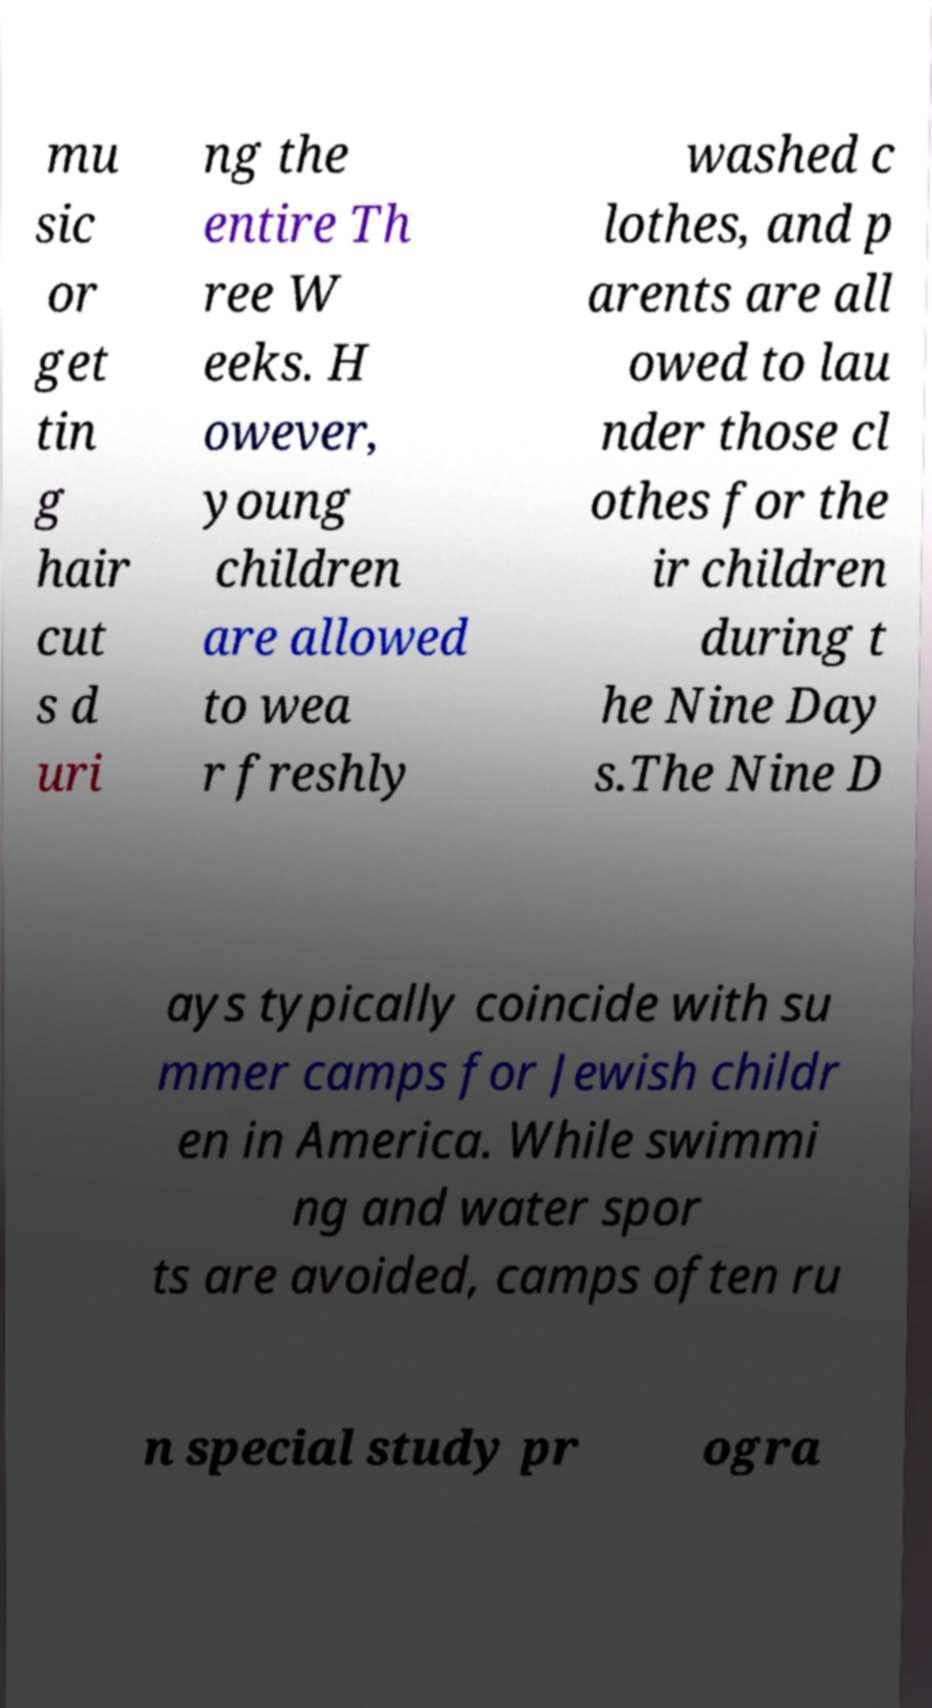Can you accurately transcribe the text from the provided image for me? mu sic or get tin g hair cut s d uri ng the entire Th ree W eeks. H owever, young children are allowed to wea r freshly washed c lothes, and p arents are all owed to lau nder those cl othes for the ir children during t he Nine Day s.The Nine D ays typically coincide with su mmer camps for Jewish childr en in America. While swimmi ng and water spor ts are avoided, camps often ru n special study pr ogra 